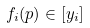Convert formula to latex. <formula><loc_0><loc_0><loc_500><loc_500>f _ { i } ( p ) \in [ y _ { i } ]</formula> 